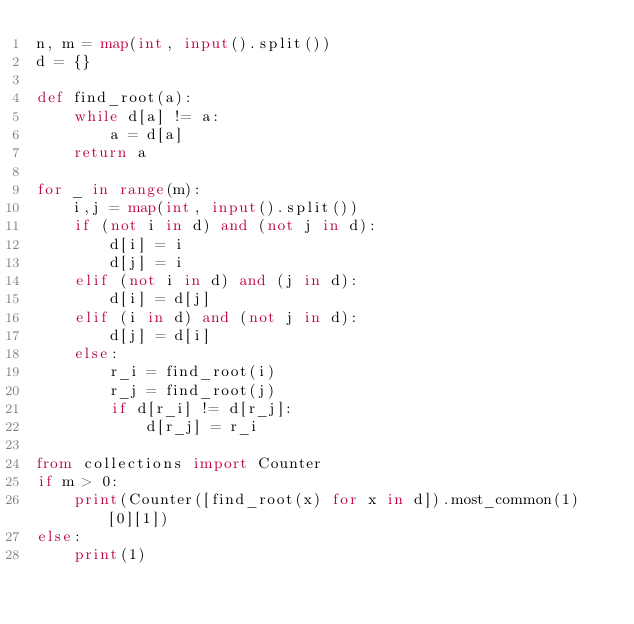<code> <loc_0><loc_0><loc_500><loc_500><_Python_>n, m = map(int, input().split())
d = {}

def find_root(a):
    while d[a] != a:
        a = d[a]
    return a
    
for _ in range(m):
    i,j = map(int, input().split())
    if (not i in d) and (not j in d):
        d[i] = i
        d[j] = i
    elif (not i in d) and (j in d):
        d[i] = d[j]
    elif (i in d) and (not j in d):
        d[j] = d[i]
    else:
        r_i = find_root(i)
        r_j = find_root(j)
        if d[r_i] != d[r_j]:
            d[r_j] = r_i
            
from collections import Counter
if m > 0:
    print(Counter([find_root(x) for x in d]).most_common(1)[0][1])
else:
    print(1)</code> 